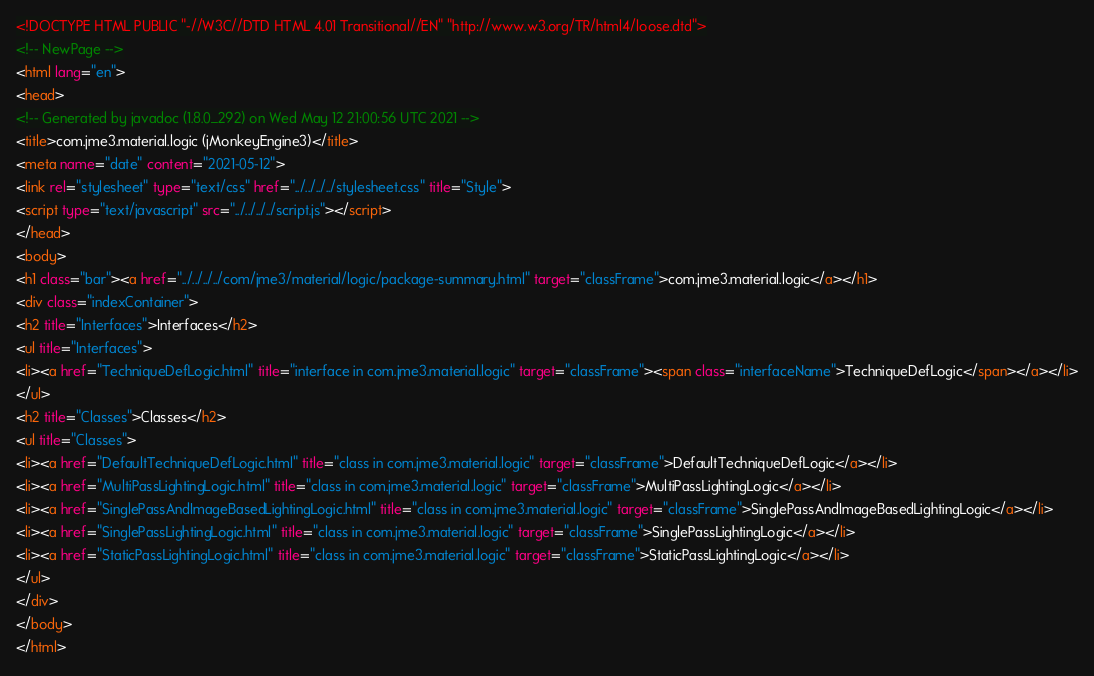Convert code to text. <code><loc_0><loc_0><loc_500><loc_500><_HTML_><!DOCTYPE HTML PUBLIC "-//W3C//DTD HTML 4.01 Transitional//EN" "http://www.w3.org/TR/html4/loose.dtd">
<!-- NewPage -->
<html lang="en">
<head>
<!-- Generated by javadoc (1.8.0_292) on Wed May 12 21:00:56 UTC 2021 -->
<title>com.jme3.material.logic (jMonkeyEngine3)</title>
<meta name="date" content="2021-05-12">
<link rel="stylesheet" type="text/css" href="../../../../stylesheet.css" title="Style">
<script type="text/javascript" src="../../../../script.js"></script>
</head>
<body>
<h1 class="bar"><a href="../../../../com/jme3/material/logic/package-summary.html" target="classFrame">com.jme3.material.logic</a></h1>
<div class="indexContainer">
<h2 title="Interfaces">Interfaces</h2>
<ul title="Interfaces">
<li><a href="TechniqueDefLogic.html" title="interface in com.jme3.material.logic" target="classFrame"><span class="interfaceName">TechniqueDefLogic</span></a></li>
</ul>
<h2 title="Classes">Classes</h2>
<ul title="Classes">
<li><a href="DefaultTechniqueDefLogic.html" title="class in com.jme3.material.logic" target="classFrame">DefaultTechniqueDefLogic</a></li>
<li><a href="MultiPassLightingLogic.html" title="class in com.jme3.material.logic" target="classFrame">MultiPassLightingLogic</a></li>
<li><a href="SinglePassAndImageBasedLightingLogic.html" title="class in com.jme3.material.logic" target="classFrame">SinglePassAndImageBasedLightingLogic</a></li>
<li><a href="SinglePassLightingLogic.html" title="class in com.jme3.material.logic" target="classFrame">SinglePassLightingLogic</a></li>
<li><a href="StaticPassLightingLogic.html" title="class in com.jme3.material.logic" target="classFrame">StaticPassLightingLogic</a></li>
</ul>
</div>
</body>
</html>
</code> 